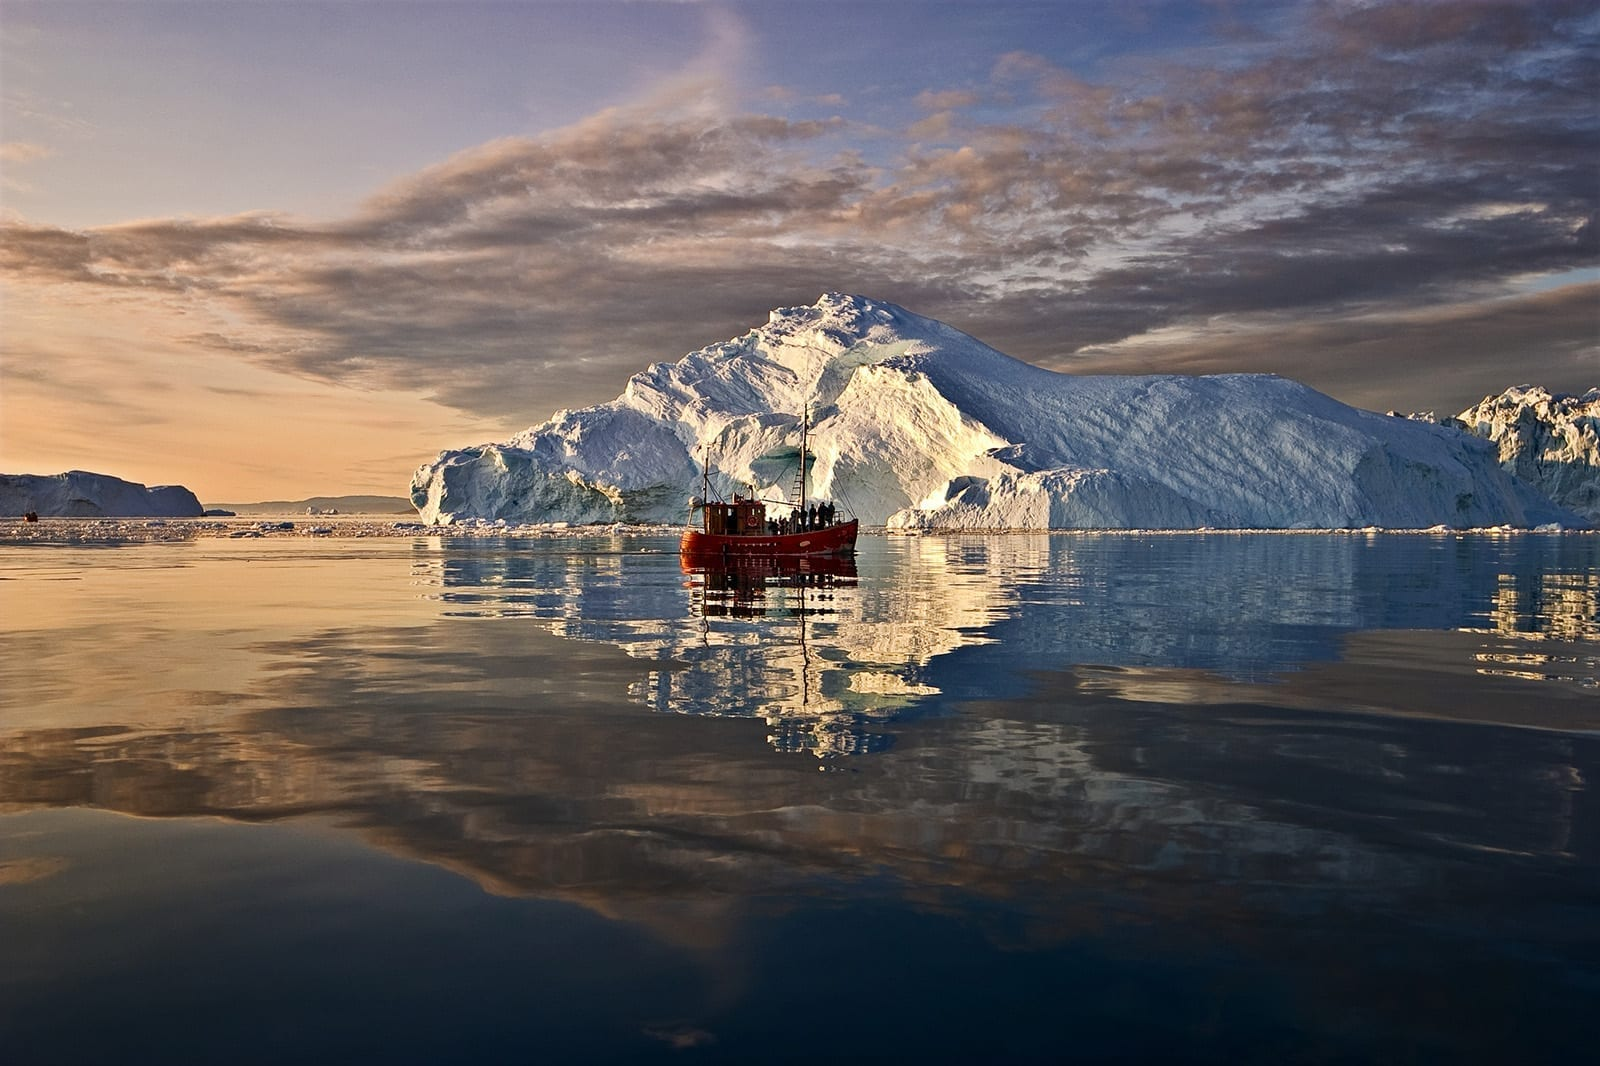What might be the environmental importance of the Ilulissat Icefjord? The Ilulissat Icefjord is pivotal for environmental studies because it provides a real-time view of how rapid glacial retreat and iceberg calving are being affected by climate change. Researchers observe and record the rate at which the ice is moving and melting, gaining valuable insights into the patterns of natural ice production and its implications on sea-level rise. Additionally, the rich biodiversity in the surrounding area, both marine and terrestrial, offers opportunities to study the ecological impact of the changing climate on local species. 